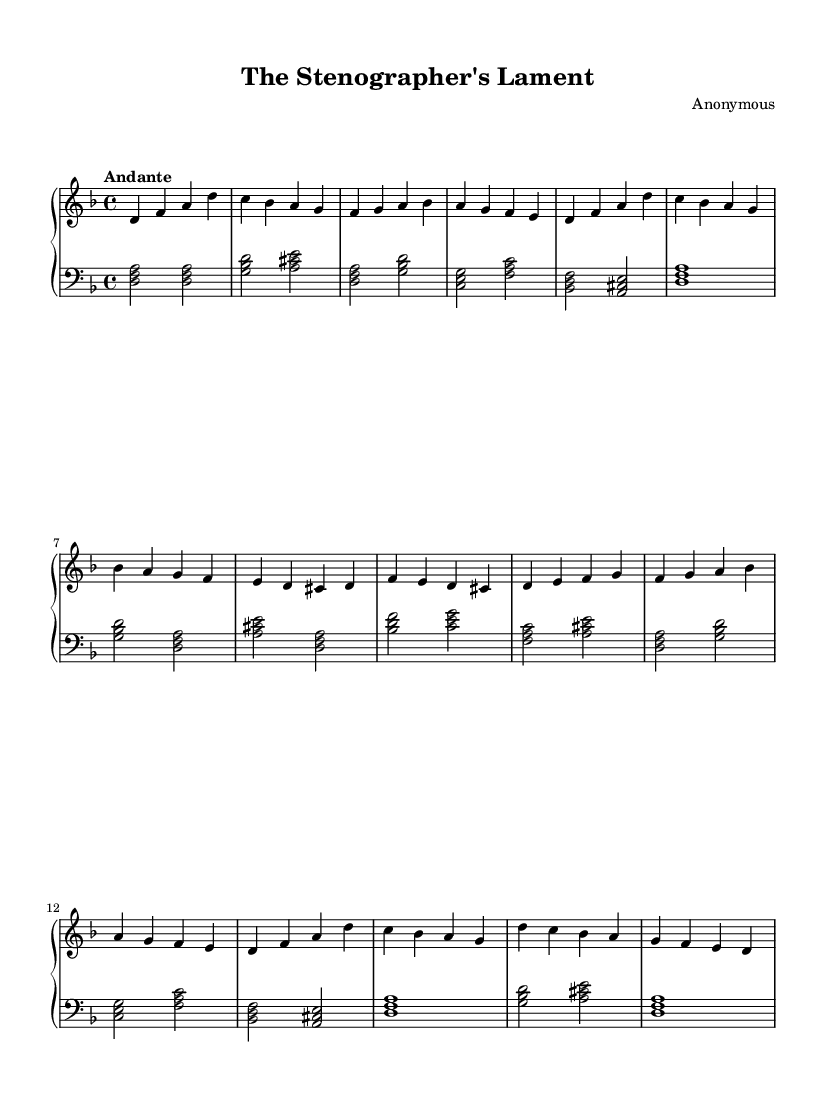What is the key signature of this music? The key signature indicated in the music is one flat, signifying the key of D minor.
Answer: D minor What is the time signature of this music? The time signature shown in the sheet music is 4/4, meaning there are four beats in each measure and the quarter note gets one beat.
Answer: 4/4 What is the tempo marking for this composition? The tempo marking on the sheet music indicates "Andante," which suggests a moderate walking pace.
Answer: Andante How many measures are in section A of the piece? By counting the measures labeled under section A of the sheet music, we can see that it consists of 8 measures.
Answer: 8 What chord is played at the beginning of the piece? The first chord indicated in the left hand is a D minor chord, made up of the notes D, F, and A.
Answer: D minor Which section has a different melody compared to section A? Section B has a different melody when compared to Section A, providing a contrast to the established themes.
Answer: Section B What does the coda signify in a musical composition? The coda indicates a concluding passage that wraps up the composition, often summarizing themes or motifs.
Answer: Concluding passage 